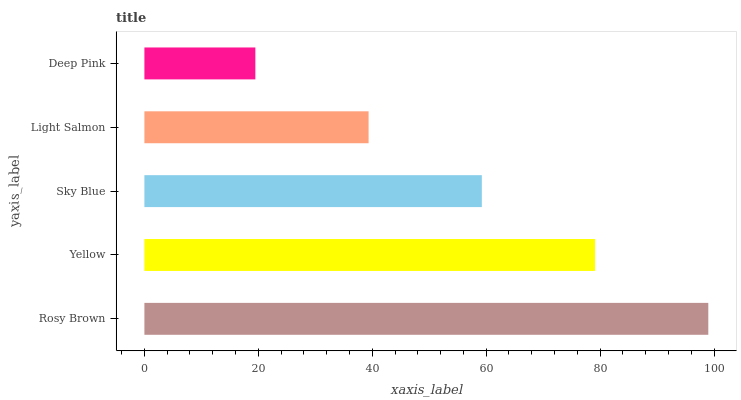Is Deep Pink the minimum?
Answer yes or no. Yes. Is Rosy Brown the maximum?
Answer yes or no. Yes. Is Yellow the minimum?
Answer yes or no. No. Is Yellow the maximum?
Answer yes or no. No. Is Rosy Brown greater than Yellow?
Answer yes or no. Yes. Is Yellow less than Rosy Brown?
Answer yes or no. Yes. Is Yellow greater than Rosy Brown?
Answer yes or no. No. Is Rosy Brown less than Yellow?
Answer yes or no. No. Is Sky Blue the high median?
Answer yes or no. Yes. Is Sky Blue the low median?
Answer yes or no. Yes. Is Light Salmon the high median?
Answer yes or no. No. Is Rosy Brown the low median?
Answer yes or no. No. 